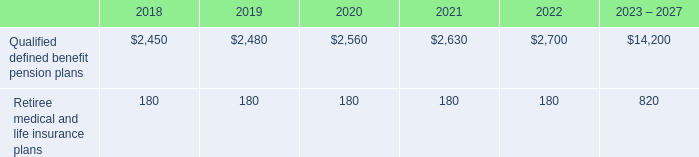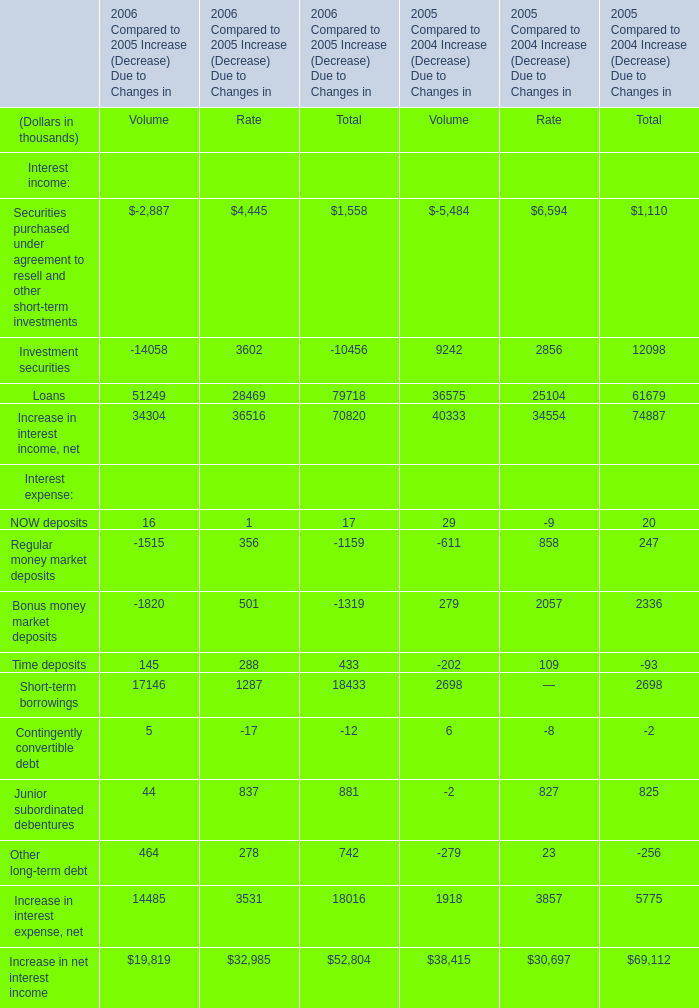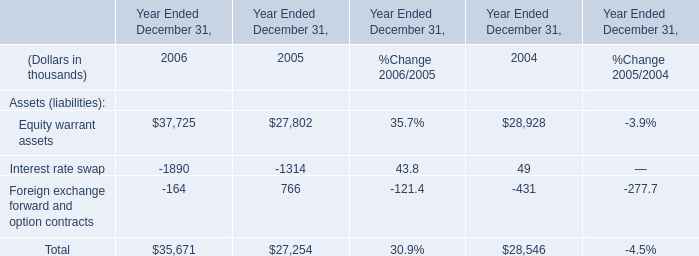what was the percentage change in the employee total matching contributions from 2015 to 2016 
Computations: ((617 - 393) / 393)
Answer: 0.56997. 